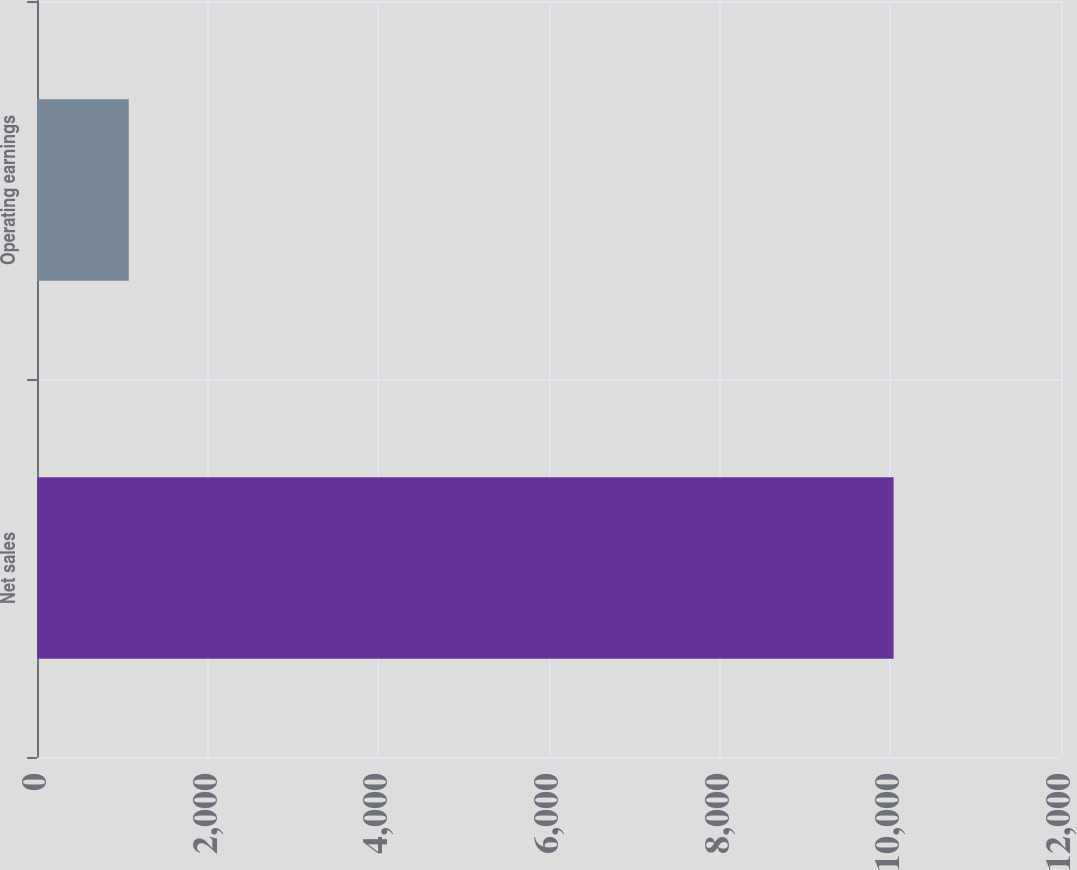<chart> <loc_0><loc_0><loc_500><loc_500><bar_chart><fcel>Net sales<fcel>Operating earnings<nl><fcel>10038<fcel>1075<nl></chart> 